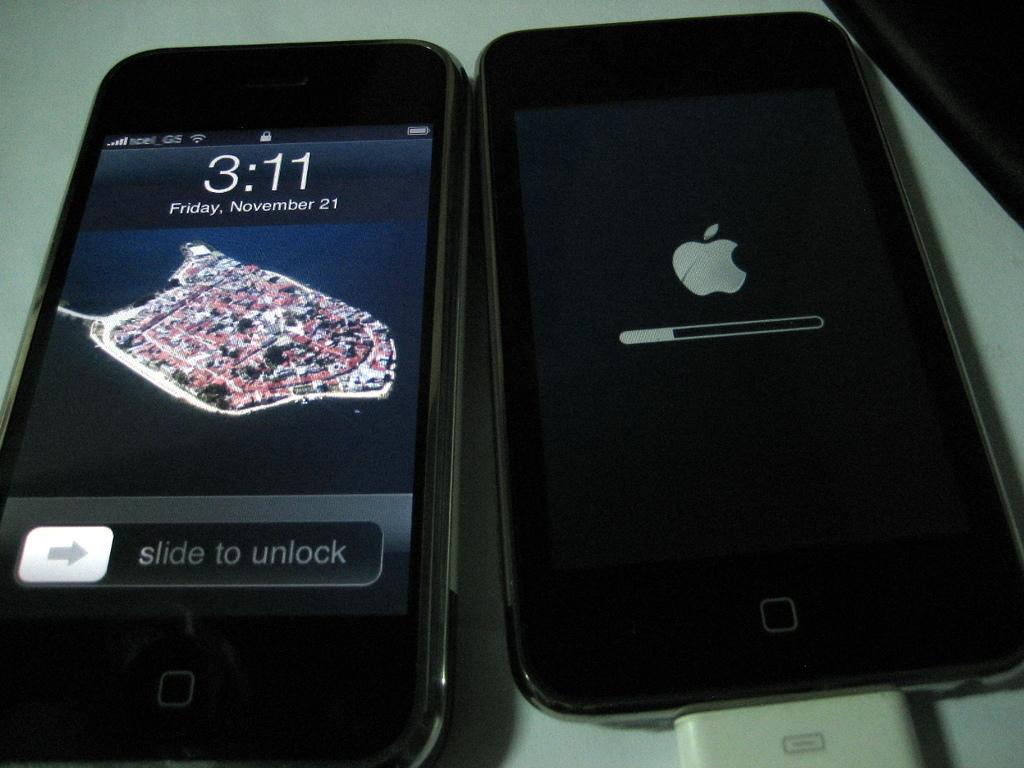<image>
Share a concise interpretation of the image provided. Two phones side by side with one showing the time at 3:11. 